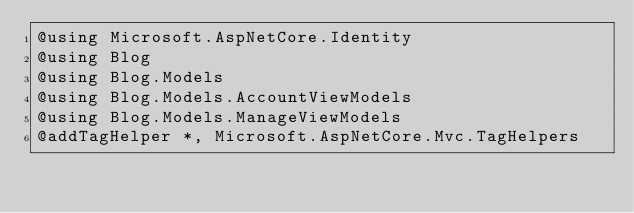Convert code to text. <code><loc_0><loc_0><loc_500><loc_500><_C#_>@using Microsoft.AspNetCore.Identity
@using Blog
@using Blog.Models
@using Blog.Models.AccountViewModels
@using Blog.Models.ManageViewModels
@addTagHelper *, Microsoft.AspNetCore.Mvc.TagHelpers</code> 